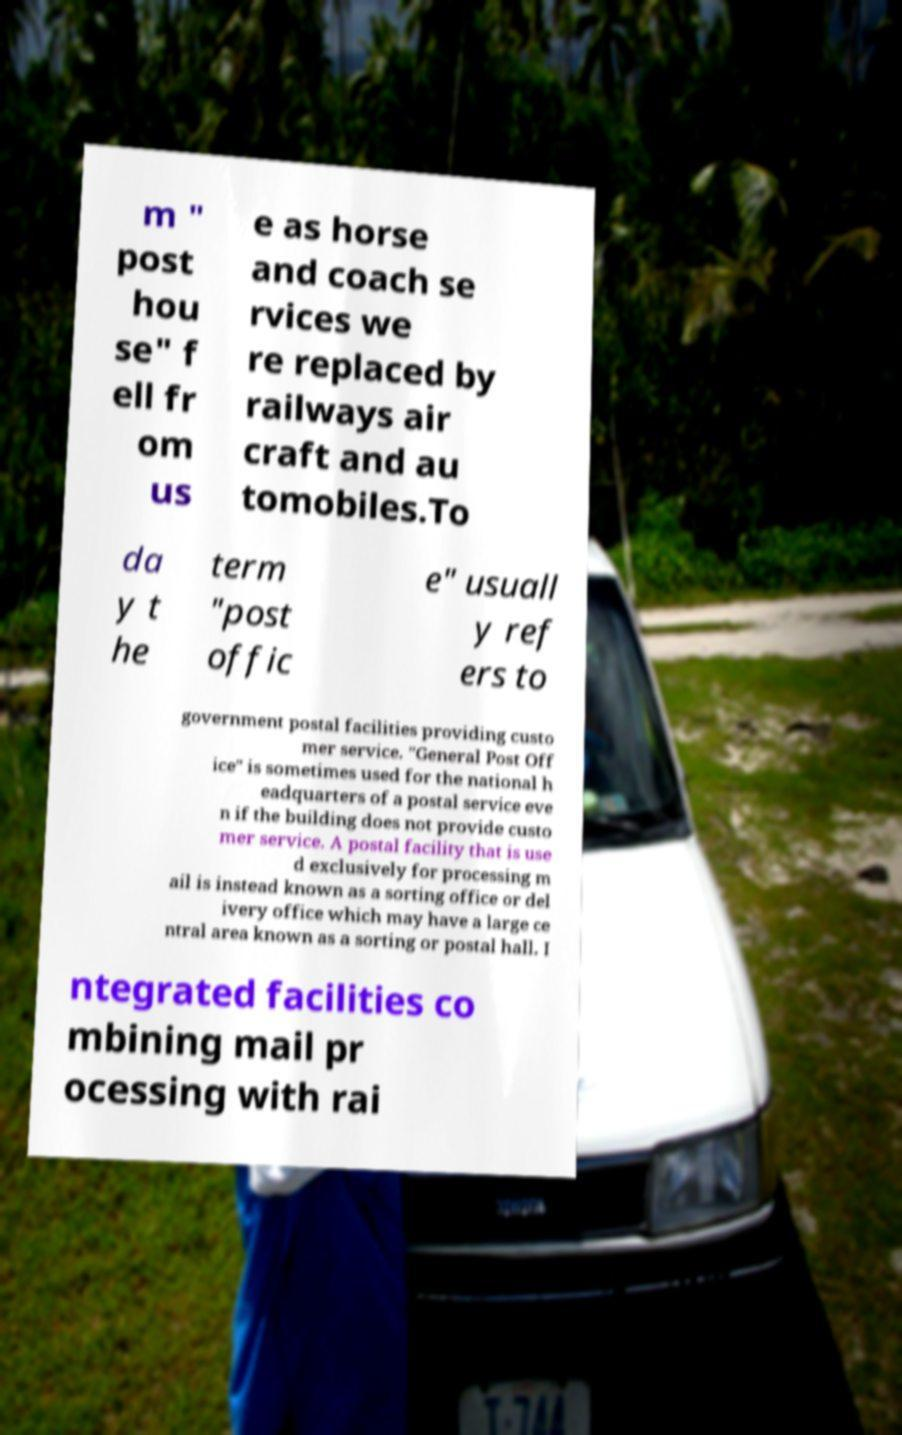Can you read and provide the text displayed in the image?This photo seems to have some interesting text. Can you extract and type it out for me? m " post hou se" f ell fr om us e as horse and coach se rvices we re replaced by railways air craft and au tomobiles.To da y t he term "post offic e" usuall y ref ers to government postal facilities providing custo mer service. "General Post Off ice" is sometimes used for the national h eadquarters of a postal service eve n if the building does not provide custo mer service. A postal facility that is use d exclusively for processing m ail is instead known as a sorting office or del ivery office which may have a large ce ntral area known as a sorting or postal hall. I ntegrated facilities co mbining mail pr ocessing with rai 